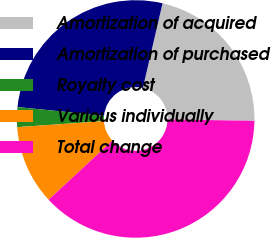Convert chart to OTSL. <chart><loc_0><loc_0><loc_500><loc_500><pie_chart><fcel>Amortization of acquired<fcel>Amortization of purchased<fcel>Royalty cost<fcel>Various individually<fcel>Total change<nl><fcel>21.62%<fcel>27.03%<fcel>2.7%<fcel>10.81%<fcel>37.84%<nl></chart> 